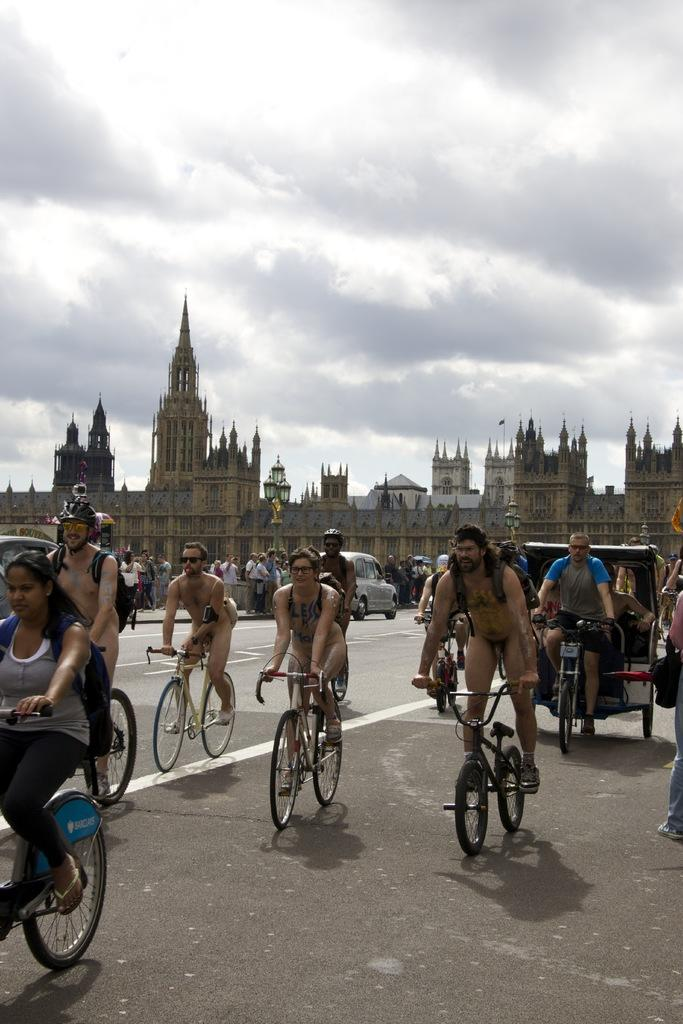What are the people in the image doing? The people in the image are riding bicycles. What else can be seen in the image besides the people on bicycles? There are vehicles, a building in the background, people standing in the middle of the image, a road, and a cloudy sky visible in the image. What type of verse can be heard being recited by the jar in the image? There is no jar or verse present in the image. What causes the burst of laughter among the people in the image? There is no burst of laughter or specific event causing it in the image. 